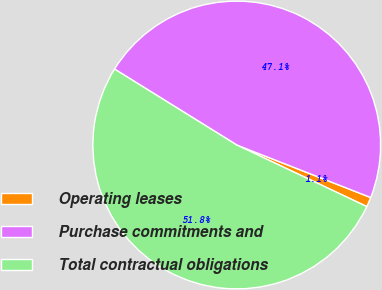<chart> <loc_0><loc_0><loc_500><loc_500><pie_chart><fcel>Operating leases<fcel>Purchase commitments and<fcel>Total contractual obligations<nl><fcel>1.09%<fcel>47.1%<fcel>51.81%<nl></chart> 